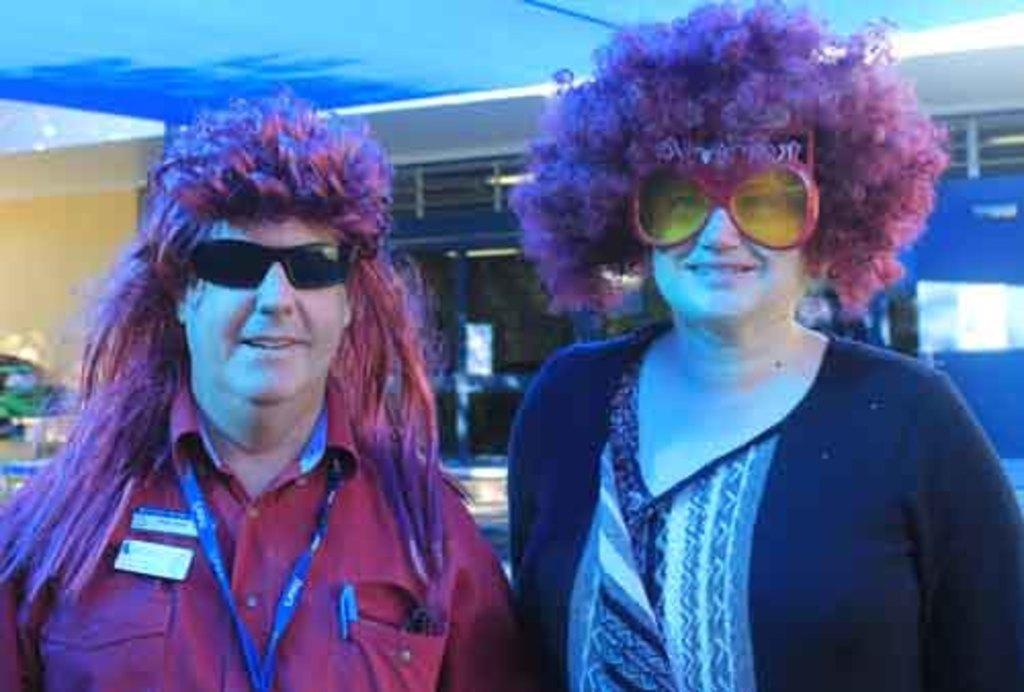How many people are in the image? There are two persons in the image. What expressions do the persons have? The persons are smiling. What accessories are the persons wearing? The persons are wearing wigs and goggles. What can be seen in the background of the image? There is a glass-like object in the background of the image. How would you describe the background of the image? The background of the image is blurry. What type of fear can be seen on the grandmother's face in the image? There is no grandmother present in the image, and therefore no such expression can be observed. 